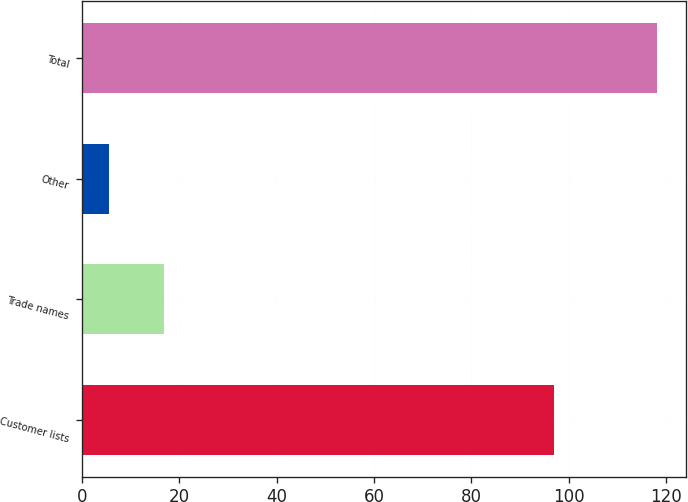Convert chart. <chart><loc_0><loc_0><loc_500><loc_500><bar_chart><fcel>Customer lists<fcel>Trade names<fcel>Other<fcel>Total<nl><fcel>96.9<fcel>16.94<fcel>5.7<fcel>118.1<nl></chart> 